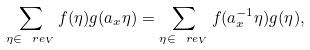<formula> <loc_0><loc_0><loc_500><loc_500>\sum _ { \eta \in \ r e _ { V } } f ( \eta ) g ( a _ { x } \eta ) = \sum _ { \eta \in \ r e _ { V } } f ( a _ { x } ^ { - 1 } \eta ) g ( \eta ) ,</formula> 